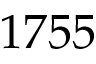<formula> <loc_0><loc_0><loc_500><loc_500>1 7 5 5</formula> 